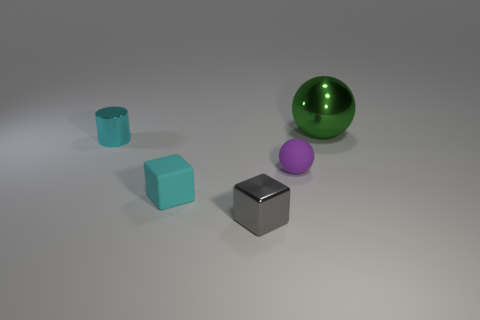Add 1 green things. How many objects exist? 6 Subtract all blocks. How many objects are left? 3 Add 4 purple matte things. How many purple matte things are left? 5 Add 3 small spheres. How many small spheres exist? 4 Subtract 1 green balls. How many objects are left? 4 Subtract all small cyan things. Subtract all tiny blue metal cylinders. How many objects are left? 3 